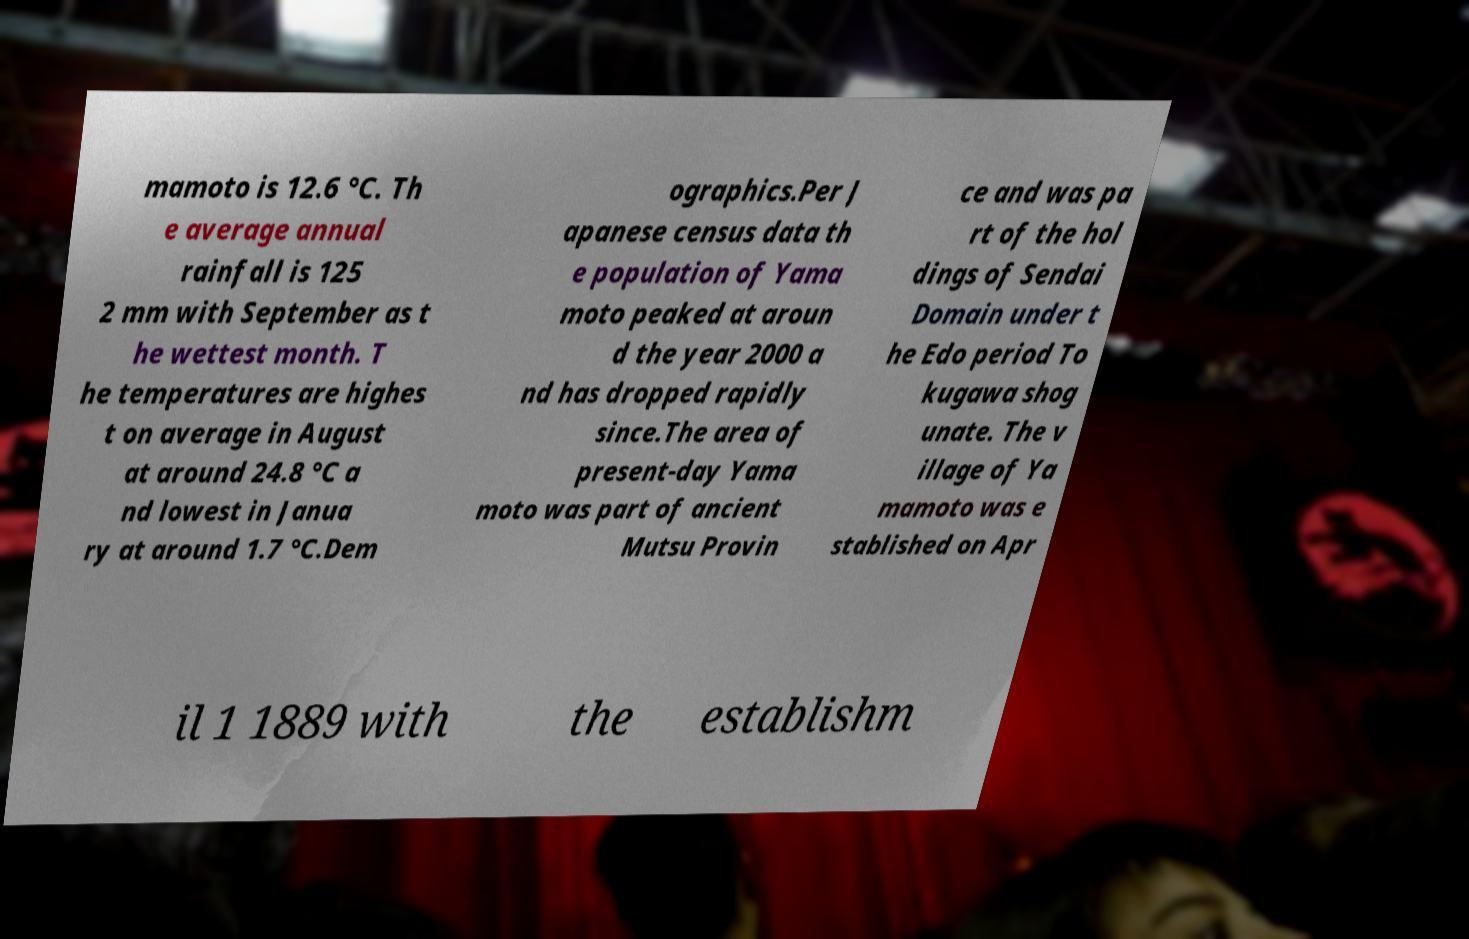Can you accurately transcribe the text from the provided image for me? mamoto is 12.6 °C. Th e average annual rainfall is 125 2 mm with September as t he wettest month. T he temperatures are highes t on average in August at around 24.8 °C a nd lowest in Janua ry at around 1.7 °C.Dem ographics.Per J apanese census data th e population of Yama moto peaked at aroun d the year 2000 a nd has dropped rapidly since.The area of present-day Yama moto was part of ancient Mutsu Provin ce and was pa rt of the hol dings of Sendai Domain under t he Edo period To kugawa shog unate. The v illage of Ya mamoto was e stablished on Apr il 1 1889 with the establishm 